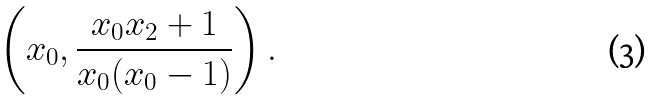Convert formula to latex. <formula><loc_0><loc_0><loc_500><loc_500>\left ( x _ { 0 } , \frac { x _ { 0 } x _ { 2 } + 1 } { x _ { 0 } ( x _ { 0 } - 1 ) } \right ) .</formula> 